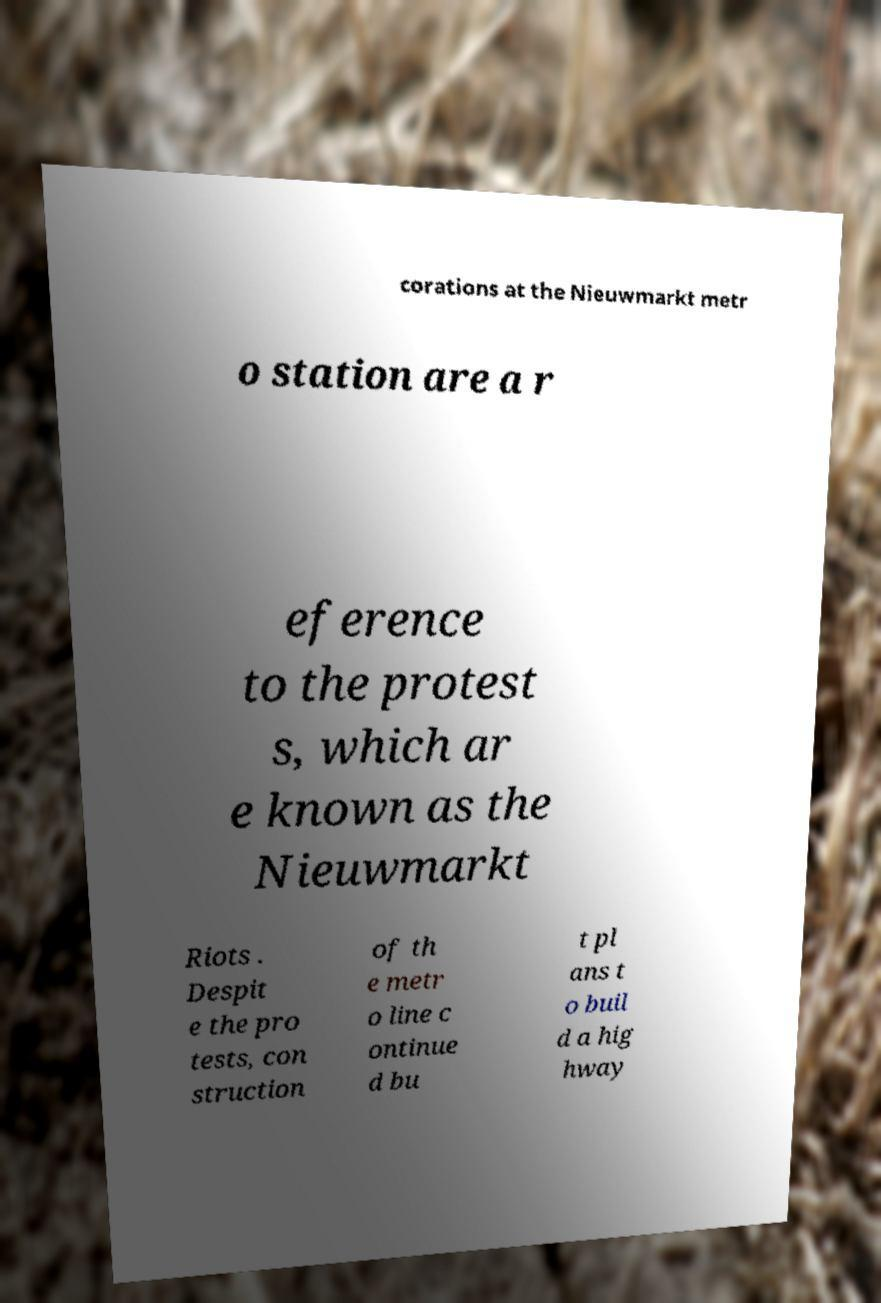What messages or text are displayed in this image? I need them in a readable, typed format. corations at the Nieuwmarkt metr o station are a r eference to the protest s, which ar e known as the Nieuwmarkt Riots . Despit e the pro tests, con struction of th e metr o line c ontinue d bu t pl ans t o buil d a hig hway 